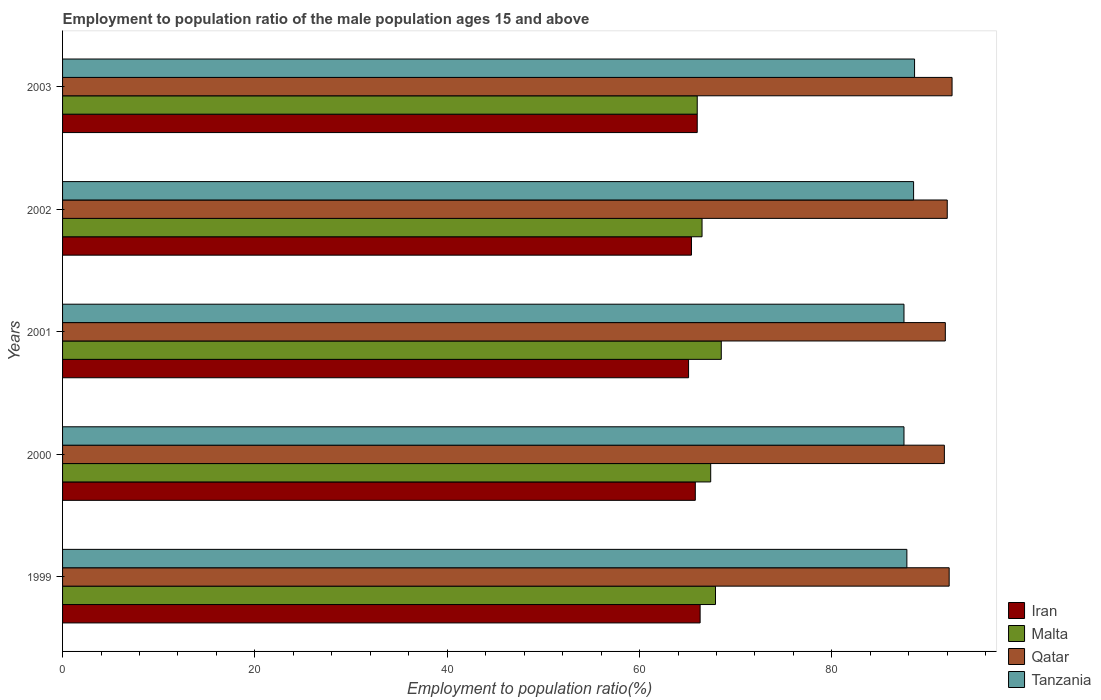How many different coloured bars are there?
Provide a short and direct response. 4. How many groups of bars are there?
Provide a short and direct response. 5. Are the number of bars per tick equal to the number of legend labels?
Offer a terse response. Yes. Are the number of bars on each tick of the Y-axis equal?
Make the answer very short. Yes. How many bars are there on the 2nd tick from the top?
Make the answer very short. 4. How many bars are there on the 3rd tick from the bottom?
Your response must be concise. 4. What is the employment to population ratio in Tanzania in 1999?
Keep it short and to the point. 87.8. Across all years, what is the maximum employment to population ratio in Iran?
Keep it short and to the point. 66.3. Across all years, what is the minimum employment to population ratio in Tanzania?
Offer a terse response. 87.5. In which year was the employment to population ratio in Malta maximum?
Your answer should be very brief. 2001. In which year was the employment to population ratio in Malta minimum?
Offer a very short reply. 2003. What is the total employment to population ratio in Tanzania in the graph?
Offer a terse response. 439.9. What is the difference between the employment to population ratio in Tanzania in 2002 and that in 2003?
Provide a succinct answer. -0.1. What is the difference between the employment to population ratio in Malta in 2000 and the employment to population ratio in Tanzania in 2002?
Make the answer very short. -21.1. What is the average employment to population ratio in Qatar per year?
Keep it short and to the point. 92.04. In the year 2000, what is the difference between the employment to population ratio in Malta and employment to population ratio in Tanzania?
Provide a short and direct response. -20.1. What is the ratio of the employment to population ratio in Tanzania in 2000 to that in 2003?
Offer a very short reply. 0.99. Is the difference between the employment to population ratio in Malta in 1999 and 2000 greater than the difference between the employment to population ratio in Tanzania in 1999 and 2000?
Your answer should be very brief. Yes. What is the difference between the highest and the second highest employment to population ratio in Tanzania?
Your answer should be compact. 0.1. What is the difference between the highest and the lowest employment to population ratio in Iran?
Ensure brevity in your answer.  1.2. Is the sum of the employment to population ratio in Tanzania in 2001 and 2003 greater than the maximum employment to population ratio in Iran across all years?
Your answer should be compact. Yes. Is it the case that in every year, the sum of the employment to population ratio in Tanzania and employment to population ratio in Iran is greater than the sum of employment to population ratio in Malta and employment to population ratio in Qatar?
Offer a terse response. No. What does the 3rd bar from the top in 2002 represents?
Your response must be concise. Malta. What does the 1st bar from the bottom in 2003 represents?
Give a very brief answer. Iran. How many bars are there?
Offer a very short reply. 20. How many years are there in the graph?
Your answer should be compact. 5. Are the values on the major ticks of X-axis written in scientific E-notation?
Provide a succinct answer. No. Does the graph contain any zero values?
Your answer should be very brief. No. Does the graph contain grids?
Offer a very short reply. No. How are the legend labels stacked?
Make the answer very short. Vertical. What is the title of the graph?
Your response must be concise. Employment to population ratio of the male population ages 15 and above. What is the label or title of the X-axis?
Provide a succinct answer. Employment to population ratio(%). What is the Employment to population ratio(%) of Iran in 1999?
Give a very brief answer. 66.3. What is the Employment to population ratio(%) of Malta in 1999?
Your answer should be compact. 67.9. What is the Employment to population ratio(%) in Qatar in 1999?
Offer a terse response. 92.2. What is the Employment to population ratio(%) in Tanzania in 1999?
Make the answer very short. 87.8. What is the Employment to population ratio(%) of Iran in 2000?
Offer a very short reply. 65.8. What is the Employment to population ratio(%) of Malta in 2000?
Ensure brevity in your answer.  67.4. What is the Employment to population ratio(%) in Qatar in 2000?
Offer a very short reply. 91.7. What is the Employment to population ratio(%) of Tanzania in 2000?
Ensure brevity in your answer.  87.5. What is the Employment to population ratio(%) in Iran in 2001?
Give a very brief answer. 65.1. What is the Employment to population ratio(%) in Malta in 2001?
Your answer should be very brief. 68.5. What is the Employment to population ratio(%) in Qatar in 2001?
Give a very brief answer. 91.8. What is the Employment to population ratio(%) of Tanzania in 2001?
Give a very brief answer. 87.5. What is the Employment to population ratio(%) of Iran in 2002?
Ensure brevity in your answer.  65.4. What is the Employment to population ratio(%) in Malta in 2002?
Your response must be concise. 66.5. What is the Employment to population ratio(%) in Qatar in 2002?
Give a very brief answer. 92. What is the Employment to population ratio(%) in Tanzania in 2002?
Provide a succinct answer. 88.5. What is the Employment to population ratio(%) of Qatar in 2003?
Your answer should be very brief. 92.5. What is the Employment to population ratio(%) in Tanzania in 2003?
Your answer should be compact. 88.6. Across all years, what is the maximum Employment to population ratio(%) of Iran?
Provide a short and direct response. 66.3. Across all years, what is the maximum Employment to population ratio(%) in Malta?
Your response must be concise. 68.5. Across all years, what is the maximum Employment to population ratio(%) of Qatar?
Provide a succinct answer. 92.5. Across all years, what is the maximum Employment to population ratio(%) in Tanzania?
Offer a terse response. 88.6. Across all years, what is the minimum Employment to population ratio(%) of Iran?
Provide a succinct answer. 65.1. Across all years, what is the minimum Employment to population ratio(%) of Qatar?
Provide a succinct answer. 91.7. Across all years, what is the minimum Employment to population ratio(%) of Tanzania?
Offer a terse response. 87.5. What is the total Employment to population ratio(%) in Iran in the graph?
Your response must be concise. 328.6. What is the total Employment to population ratio(%) in Malta in the graph?
Ensure brevity in your answer.  336.3. What is the total Employment to population ratio(%) of Qatar in the graph?
Offer a terse response. 460.2. What is the total Employment to population ratio(%) in Tanzania in the graph?
Your answer should be compact. 439.9. What is the difference between the Employment to population ratio(%) of Iran in 1999 and that in 2000?
Keep it short and to the point. 0.5. What is the difference between the Employment to population ratio(%) in Qatar in 1999 and that in 2000?
Give a very brief answer. 0.5. What is the difference between the Employment to population ratio(%) in Qatar in 1999 and that in 2001?
Your answer should be very brief. 0.4. What is the difference between the Employment to population ratio(%) of Malta in 1999 and that in 2002?
Provide a short and direct response. 1.4. What is the difference between the Employment to population ratio(%) of Iran in 1999 and that in 2003?
Give a very brief answer. 0.3. What is the difference between the Employment to population ratio(%) in Malta in 1999 and that in 2003?
Keep it short and to the point. 1.9. What is the difference between the Employment to population ratio(%) of Qatar in 1999 and that in 2003?
Provide a short and direct response. -0.3. What is the difference between the Employment to population ratio(%) in Tanzania in 1999 and that in 2003?
Make the answer very short. -0.8. What is the difference between the Employment to population ratio(%) in Iran in 2000 and that in 2001?
Your answer should be very brief. 0.7. What is the difference between the Employment to population ratio(%) in Malta in 2000 and that in 2001?
Ensure brevity in your answer.  -1.1. What is the difference between the Employment to population ratio(%) of Qatar in 2000 and that in 2001?
Keep it short and to the point. -0.1. What is the difference between the Employment to population ratio(%) of Tanzania in 2000 and that in 2001?
Provide a succinct answer. 0. What is the difference between the Employment to population ratio(%) of Malta in 2000 and that in 2003?
Offer a terse response. 1.4. What is the difference between the Employment to population ratio(%) in Qatar in 2000 and that in 2003?
Ensure brevity in your answer.  -0.8. What is the difference between the Employment to population ratio(%) in Tanzania in 2000 and that in 2003?
Your answer should be compact. -1.1. What is the difference between the Employment to population ratio(%) in Malta in 2001 and that in 2002?
Offer a terse response. 2. What is the difference between the Employment to population ratio(%) of Tanzania in 2001 and that in 2002?
Offer a terse response. -1. What is the difference between the Employment to population ratio(%) in Iran in 2002 and that in 2003?
Provide a succinct answer. -0.6. What is the difference between the Employment to population ratio(%) in Qatar in 2002 and that in 2003?
Offer a terse response. -0.5. What is the difference between the Employment to population ratio(%) in Iran in 1999 and the Employment to population ratio(%) in Malta in 2000?
Offer a very short reply. -1.1. What is the difference between the Employment to population ratio(%) in Iran in 1999 and the Employment to population ratio(%) in Qatar in 2000?
Offer a very short reply. -25.4. What is the difference between the Employment to population ratio(%) in Iran in 1999 and the Employment to population ratio(%) in Tanzania in 2000?
Make the answer very short. -21.2. What is the difference between the Employment to population ratio(%) of Malta in 1999 and the Employment to population ratio(%) of Qatar in 2000?
Provide a short and direct response. -23.8. What is the difference between the Employment to population ratio(%) in Malta in 1999 and the Employment to population ratio(%) in Tanzania in 2000?
Make the answer very short. -19.6. What is the difference between the Employment to population ratio(%) of Qatar in 1999 and the Employment to population ratio(%) of Tanzania in 2000?
Your response must be concise. 4.7. What is the difference between the Employment to population ratio(%) of Iran in 1999 and the Employment to population ratio(%) of Malta in 2001?
Offer a very short reply. -2.2. What is the difference between the Employment to population ratio(%) of Iran in 1999 and the Employment to population ratio(%) of Qatar in 2001?
Your response must be concise. -25.5. What is the difference between the Employment to population ratio(%) in Iran in 1999 and the Employment to population ratio(%) in Tanzania in 2001?
Offer a very short reply. -21.2. What is the difference between the Employment to population ratio(%) in Malta in 1999 and the Employment to population ratio(%) in Qatar in 2001?
Offer a very short reply. -23.9. What is the difference between the Employment to population ratio(%) of Malta in 1999 and the Employment to population ratio(%) of Tanzania in 2001?
Offer a very short reply. -19.6. What is the difference between the Employment to population ratio(%) of Iran in 1999 and the Employment to population ratio(%) of Malta in 2002?
Provide a succinct answer. -0.2. What is the difference between the Employment to population ratio(%) of Iran in 1999 and the Employment to population ratio(%) of Qatar in 2002?
Make the answer very short. -25.7. What is the difference between the Employment to population ratio(%) in Iran in 1999 and the Employment to population ratio(%) in Tanzania in 2002?
Make the answer very short. -22.2. What is the difference between the Employment to population ratio(%) of Malta in 1999 and the Employment to population ratio(%) of Qatar in 2002?
Make the answer very short. -24.1. What is the difference between the Employment to population ratio(%) in Malta in 1999 and the Employment to population ratio(%) in Tanzania in 2002?
Provide a succinct answer. -20.6. What is the difference between the Employment to population ratio(%) in Qatar in 1999 and the Employment to population ratio(%) in Tanzania in 2002?
Ensure brevity in your answer.  3.7. What is the difference between the Employment to population ratio(%) of Iran in 1999 and the Employment to population ratio(%) of Malta in 2003?
Your answer should be compact. 0.3. What is the difference between the Employment to population ratio(%) in Iran in 1999 and the Employment to population ratio(%) in Qatar in 2003?
Provide a short and direct response. -26.2. What is the difference between the Employment to population ratio(%) of Iran in 1999 and the Employment to population ratio(%) of Tanzania in 2003?
Offer a terse response. -22.3. What is the difference between the Employment to population ratio(%) of Malta in 1999 and the Employment to population ratio(%) of Qatar in 2003?
Provide a short and direct response. -24.6. What is the difference between the Employment to population ratio(%) of Malta in 1999 and the Employment to population ratio(%) of Tanzania in 2003?
Keep it short and to the point. -20.7. What is the difference between the Employment to population ratio(%) in Iran in 2000 and the Employment to population ratio(%) in Qatar in 2001?
Keep it short and to the point. -26. What is the difference between the Employment to population ratio(%) of Iran in 2000 and the Employment to population ratio(%) of Tanzania in 2001?
Provide a short and direct response. -21.7. What is the difference between the Employment to population ratio(%) of Malta in 2000 and the Employment to population ratio(%) of Qatar in 2001?
Provide a short and direct response. -24.4. What is the difference between the Employment to population ratio(%) in Malta in 2000 and the Employment to population ratio(%) in Tanzania in 2001?
Offer a terse response. -20.1. What is the difference between the Employment to population ratio(%) of Iran in 2000 and the Employment to population ratio(%) of Qatar in 2002?
Provide a succinct answer. -26.2. What is the difference between the Employment to population ratio(%) in Iran in 2000 and the Employment to population ratio(%) in Tanzania in 2002?
Ensure brevity in your answer.  -22.7. What is the difference between the Employment to population ratio(%) in Malta in 2000 and the Employment to population ratio(%) in Qatar in 2002?
Make the answer very short. -24.6. What is the difference between the Employment to population ratio(%) of Malta in 2000 and the Employment to population ratio(%) of Tanzania in 2002?
Make the answer very short. -21.1. What is the difference between the Employment to population ratio(%) in Iran in 2000 and the Employment to population ratio(%) in Qatar in 2003?
Provide a succinct answer. -26.7. What is the difference between the Employment to population ratio(%) in Iran in 2000 and the Employment to population ratio(%) in Tanzania in 2003?
Provide a succinct answer. -22.8. What is the difference between the Employment to population ratio(%) of Malta in 2000 and the Employment to population ratio(%) of Qatar in 2003?
Your answer should be compact. -25.1. What is the difference between the Employment to population ratio(%) of Malta in 2000 and the Employment to population ratio(%) of Tanzania in 2003?
Ensure brevity in your answer.  -21.2. What is the difference between the Employment to population ratio(%) in Qatar in 2000 and the Employment to population ratio(%) in Tanzania in 2003?
Your answer should be compact. 3.1. What is the difference between the Employment to population ratio(%) in Iran in 2001 and the Employment to population ratio(%) in Malta in 2002?
Ensure brevity in your answer.  -1.4. What is the difference between the Employment to population ratio(%) of Iran in 2001 and the Employment to population ratio(%) of Qatar in 2002?
Provide a short and direct response. -26.9. What is the difference between the Employment to population ratio(%) of Iran in 2001 and the Employment to population ratio(%) of Tanzania in 2002?
Give a very brief answer. -23.4. What is the difference between the Employment to population ratio(%) in Malta in 2001 and the Employment to population ratio(%) in Qatar in 2002?
Offer a terse response. -23.5. What is the difference between the Employment to population ratio(%) in Malta in 2001 and the Employment to population ratio(%) in Tanzania in 2002?
Provide a succinct answer. -20. What is the difference between the Employment to population ratio(%) in Iran in 2001 and the Employment to population ratio(%) in Qatar in 2003?
Offer a very short reply. -27.4. What is the difference between the Employment to population ratio(%) of Iran in 2001 and the Employment to population ratio(%) of Tanzania in 2003?
Your answer should be very brief. -23.5. What is the difference between the Employment to population ratio(%) of Malta in 2001 and the Employment to population ratio(%) of Tanzania in 2003?
Your answer should be compact. -20.1. What is the difference between the Employment to population ratio(%) in Iran in 2002 and the Employment to population ratio(%) in Qatar in 2003?
Your answer should be compact. -27.1. What is the difference between the Employment to population ratio(%) of Iran in 2002 and the Employment to population ratio(%) of Tanzania in 2003?
Ensure brevity in your answer.  -23.2. What is the difference between the Employment to population ratio(%) in Malta in 2002 and the Employment to population ratio(%) in Qatar in 2003?
Give a very brief answer. -26. What is the difference between the Employment to population ratio(%) in Malta in 2002 and the Employment to population ratio(%) in Tanzania in 2003?
Offer a very short reply. -22.1. What is the average Employment to population ratio(%) of Iran per year?
Provide a short and direct response. 65.72. What is the average Employment to population ratio(%) of Malta per year?
Provide a succinct answer. 67.26. What is the average Employment to population ratio(%) in Qatar per year?
Ensure brevity in your answer.  92.04. What is the average Employment to population ratio(%) of Tanzania per year?
Give a very brief answer. 87.98. In the year 1999, what is the difference between the Employment to population ratio(%) of Iran and Employment to population ratio(%) of Malta?
Make the answer very short. -1.6. In the year 1999, what is the difference between the Employment to population ratio(%) of Iran and Employment to population ratio(%) of Qatar?
Provide a succinct answer. -25.9. In the year 1999, what is the difference between the Employment to population ratio(%) of Iran and Employment to population ratio(%) of Tanzania?
Provide a short and direct response. -21.5. In the year 1999, what is the difference between the Employment to population ratio(%) in Malta and Employment to population ratio(%) in Qatar?
Offer a very short reply. -24.3. In the year 1999, what is the difference between the Employment to population ratio(%) in Malta and Employment to population ratio(%) in Tanzania?
Keep it short and to the point. -19.9. In the year 2000, what is the difference between the Employment to population ratio(%) in Iran and Employment to population ratio(%) in Malta?
Make the answer very short. -1.6. In the year 2000, what is the difference between the Employment to population ratio(%) of Iran and Employment to population ratio(%) of Qatar?
Give a very brief answer. -25.9. In the year 2000, what is the difference between the Employment to population ratio(%) in Iran and Employment to population ratio(%) in Tanzania?
Give a very brief answer. -21.7. In the year 2000, what is the difference between the Employment to population ratio(%) of Malta and Employment to population ratio(%) of Qatar?
Ensure brevity in your answer.  -24.3. In the year 2000, what is the difference between the Employment to population ratio(%) of Malta and Employment to population ratio(%) of Tanzania?
Provide a short and direct response. -20.1. In the year 2000, what is the difference between the Employment to population ratio(%) in Qatar and Employment to population ratio(%) in Tanzania?
Ensure brevity in your answer.  4.2. In the year 2001, what is the difference between the Employment to population ratio(%) in Iran and Employment to population ratio(%) in Qatar?
Your answer should be very brief. -26.7. In the year 2001, what is the difference between the Employment to population ratio(%) of Iran and Employment to population ratio(%) of Tanzania?
Your response must be concise. -22.4. In the year 2001, what is the difference between the Employment to population ratio(%) in Malta and Employment to population ratio(%) in Qatar?
Ensure brevity in your answer.  -23.3. In the year 2001, what is the difference between the Employment to population ratio(%) of Qatar and Employment to population ratio(%) of Tanzania?
Keep it short and to the point. 4.3. In the year 2002, what is the difference between the Employment to population ratio(%) of Iran and Employment to population ratio(%) of Qatar?
Your answer should be compact. -26.6. In the year 2002, what is the difference between the Employment to population ratio(%) of Iran and Employment to population ratio(%) of Tanzania?
Offer a terse response. -23.1. In the year 2002, what is the difference between the Employment to population ratio(%) of Malta and Employment to population ratio(%) of Qatar?
Ensure brevity in your answer.  -25.5. In the year 2002, what is the difference between the Employment to population ratio(%) in Malta and Employment to population ratio(%) in Tanzania?
Your response must be concise. -22. In the year 2003, what is the difference between the Employment to population ratio(%) of Iran and Employment to population ratio(%) of Malta?
Offer a terse response. 0. In the year 2003, what is the difference between the Employment to population ratio(%) of Iran and Employment to population ratio(%) of Qatar?
Keep it short and to the point. -26.5. In the year 2003, what is the difference between the Employment to population ratio(%) in Iran and Employment to population ratio(%) in Tanzania?
Your response must be concise. -22.6. In the year 2003, what is the difference between the Employment to population ratio(%) of Malta and Employment to population ratio(%) of Qatar?
Ensure brevity in your answer.  -26.5. In the year 2003, what is the difference between the Employment to population ratio(%) of Malta and Employment to population ratio(%) of Tanzania?
Give a very brief answer. -22.6. What is the ratio of the Employment to population ratio(%) of Iran in 1999 to that in 2000?
Ensure brevity in your answer.  1.01. What is the ratio of the Employment to population ratio(%) in Malta in 1999 to that in 2000?
Provide a succinct answer. 1.01. What is the ratio of the Employment to population ratio(%) in Qatar in 1999 to that in 2000?
Your answer should be compact. 1.01. What is the ratio of the Employment to population ratio(%) in Iran in 1999 to that in 2001?
Give a very brief answer. 1.02. What is the ratio of the Employment to population ratio(%) of Qatar in 1999 to that in 2001?
Provide a succinct answer. 1. What is the ratio of the Employment to population ratio(%) in Tanzania in 1999 to that in 2001?
Your answer should be compact. 1. What is the ratio of the Employment to population ratio(%) of Iran in 1999 to that in 2002?
Your response must be concise. 1.01. What is the ratio of the Employment to population ratio(%) in Malta in 1999 to that in 2002?
Offer a very short reply. 1.02. What is the ratio of the Employment to population ratio(%) in Qatar in 1999 to that in 2002?
Provide a short and direct response. 1. What is the ratio of the Employment to population ratio(%) in Malta in 1999 to that in 2003?
Offer a very short reply. 1.03. What is the ratio of the Employment to population ratio(%) in Tanzania in 1999 to that in 2003?
Your answer should be compact. 0.99. What is the ratio of the Employment to population ratio(%) in Iran in 2000 to that in 2001?
Your response must be concise. 1.01. What is the ratio of the Employment to population ratio(%) of Malta in 2000 to that in 2001?
Ensure brevity in your answer.  0.98. What is the ratio of the Employment to population ratio(%) of Qatar in 2000 to that in 2001?
Offer a terse response. 1. What is the ratio of the Employment to population ratio(%) in Tanzania in 2000 to that in 2001?
Keep it short and to the point. 1. What is the ratio of the Employment to population ratio(%) of Malta in 2000 to that in 2002?
Give a very brief answer. 1.01. What is the ratio of the Employment to population ratio(%) of Qatar in 2000 to that in 2002?
Ensure brevity in your answer.  1. What is the ratio of the Employment to population ratio(%) in Tanzania in 2000 to that in 2002?
Your answer should be compact. 0.99. What is the ratio of the Employment to population ratio(%) in Malta in 2000 to that in 2003?
Your response must be concise. 1.02. What is the ratio of the Employment to population ratio(%) of Tanzania in 2000 to that in 2003?
Give a very brief answer. 0.99. What is the ratio of the Employment to population ratio(%) in Malta in 2001 to that in 2002?
Give a very brief answer. 1.03. What is the ratio of the Employment to population ratio(%) of Qatar in 2001 to that in 2002?
Provide a short and direct response. 1. What is the ratio of the Employment to population ratio(%) of Tanzania in 2001 to that in 2002?
Make the answer very short. 0.99. What is the ratio of the Employment to population ratio(%) in Iran in 2001 to that in 2003?
Your answer should be compact. 0.99. What is the ratio of the Employment to population ratio(%) of Malta in 2001 to that in 2003?
Your answer should be compact. 1.04. What is the ratio of the Employment to population ratio(%) of Qatar in 2001 to that in 2003?
Offer a terse response. 0.99. What is the ratio of the Employment to population ratio(%) of Tanzania in 2001 to that in 2003?
Ensure brevity in your answer.  0.99. What is the ratio of the Employment to population ratio(%) in Iran in 2002 to that in 2003?
Offer a terse response. 0.99. What is the ratio of the Employment to population ratio(%) in Malta in 2002 to that in 2003?
Ensure brevity in your answer.  1.01. What is the ratio of the Employment to population ratio(%) in Qatar in 2002 to that in 2003?
Your response must be concise. 0.99. What is the ratio of the Employment to population ratio(%) of Tanzania in 2002 to that in 2003?
Your answer should be compact. 1. What is the difference between the highest and the second highest Employment to population ratio(%) of Tanzania?
Keep it short and to the point. 0.1. What is the difference between the highest and the lowest Employment to population ratio(%) of Malta?
Ensure brevity in your answer.  2.5. What is the difference between the highest and the lowest Employment to population ratio(%) in Qatar?
Give a very brief answer. 0.8. 